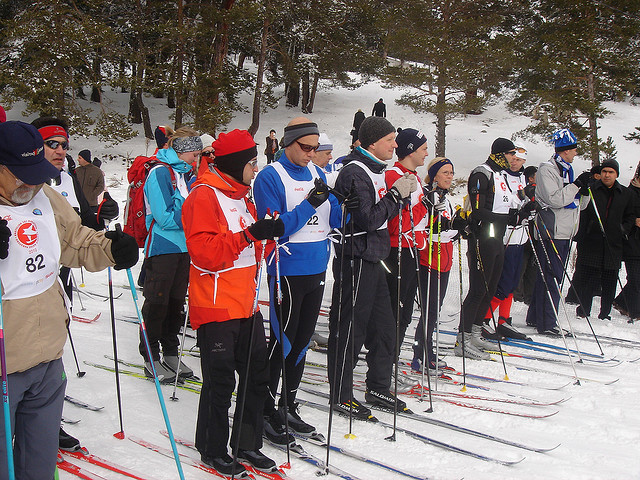Extract all visible text content from this image. 22 82 